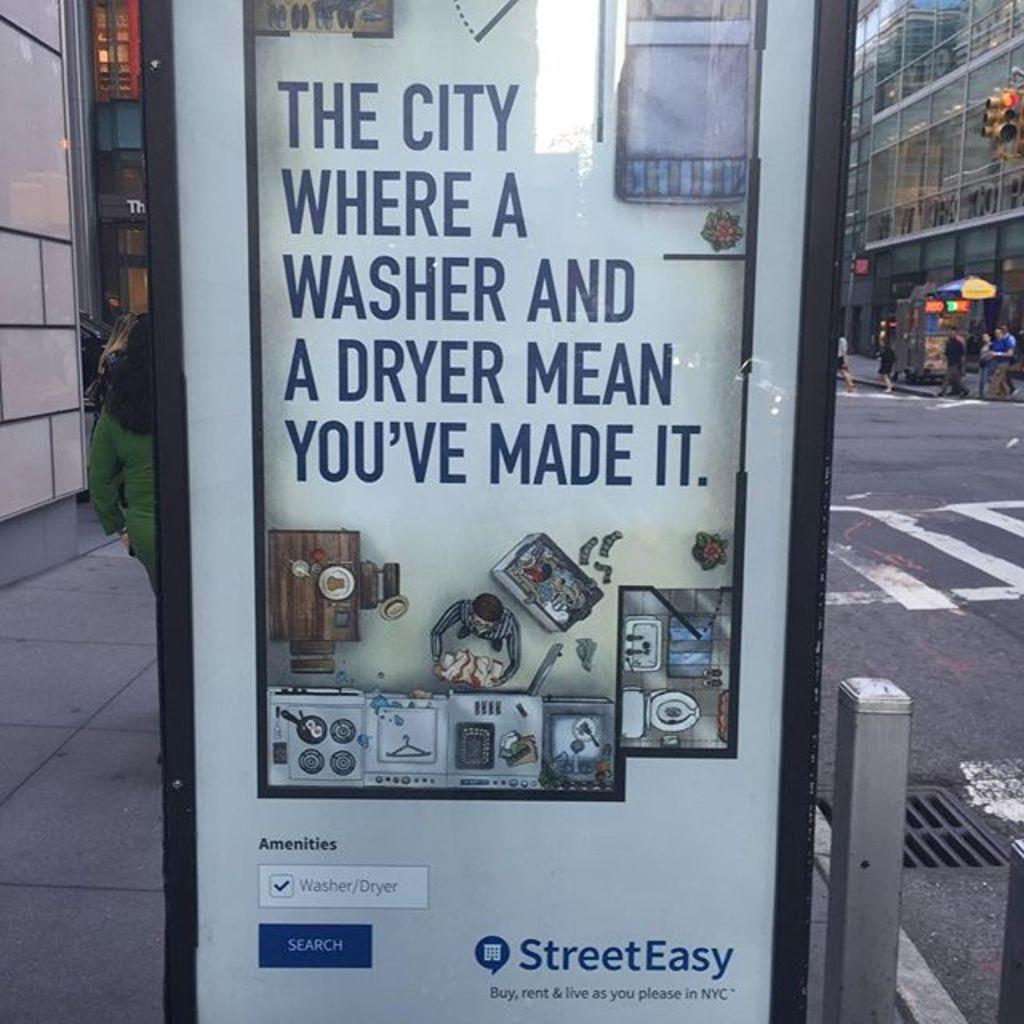<image>
Create a compact narrative representing the image presented. A sign on a bus stop reading 'The City where a washer and a dryer mean you've made it.' 